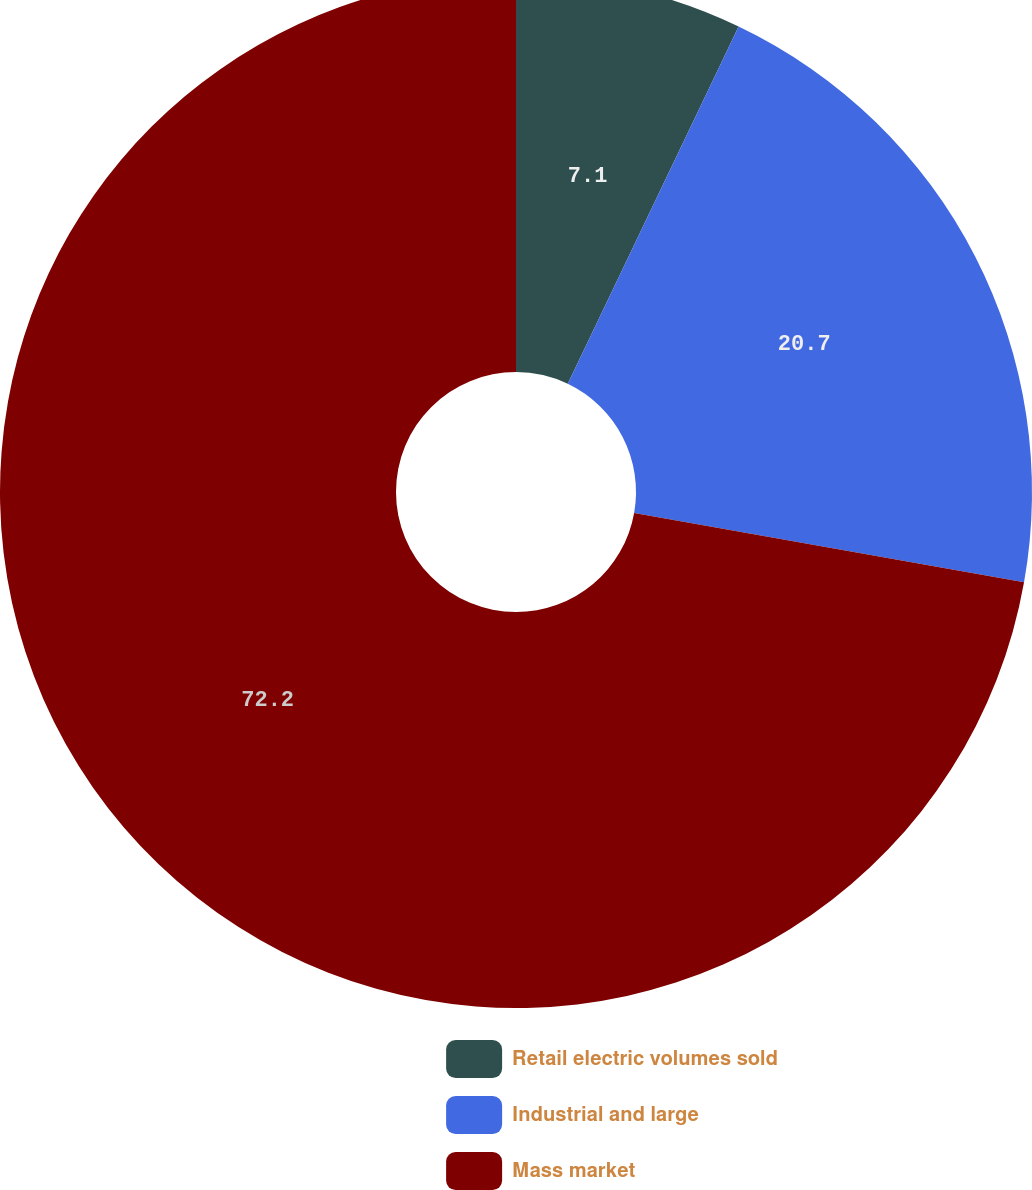Convert chart to OTSL. <chart><loc_0><loc_0><loc_500><loc_500><pie_chart><fcel>Retail electric volumes sold<fcel>Industrial and large<fcel>Mass market<nl><fcel>7.1%<fcel>20.7%<fcel>72.2%<nl></chart> 